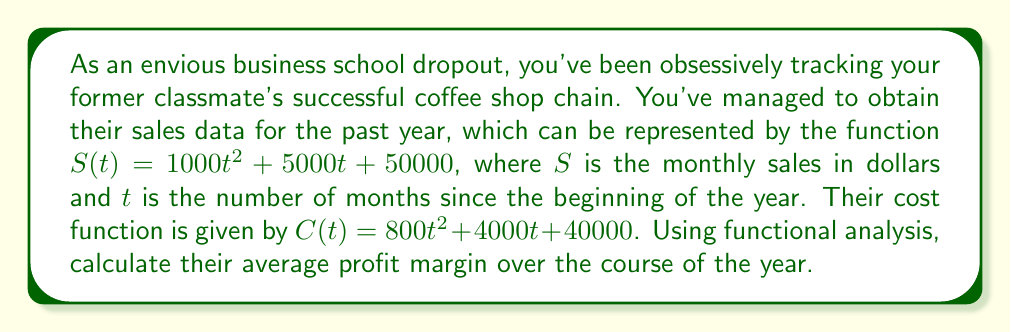What is the answer to this math problem? To solve this problem, we'll follow these steps:

1) First, let's define the profit function $P(t)$:
   $$P(t) = S(t) - C(t)$$

2) Substituting the given functions:
   $$P(t) = (1000t^2 + 5000t + 50000) - (800t^2 + 4000t + 40000)$$
   $$P(t) = 200t^2 + 1000t + 10000$$

3) To find the average profit margin, we need to calculate the average profit and the average sales over the year.

4) The average profit over the year can be calculated using the integral:
   $$\text{Average Profit} = \frac{1}{12}\int_0^{12} P(t) dt$$
   $$= \frac{1}{12}\int_0^{12} (200t^2 + 1000t + 10000) dt$$
   $$= \frac{1}{12}[\frac{200t^3}{3} + 500t^2 + 10000t]_0^{12}$$
   $$= \frac{1}{12}(11520000 + 72000000 + 120000) = 13970000$$

5) Similarly, the average sales:
   $$\text{Average Sales} = \frac{1}{12}\int_0^{12} S(t) dt$$
   $$= \frac{1}{12}\int_0^{12} (1000t^2 + 5000t + 50000) dt$$
   $$= \frac{1}{12}[\frac{1000t^3}{3} + 2500t^2 + 50000t]_0^{12}$$
   $$= \frac{1}{12}(576000000 + 360000000 + 600000) = 78050000$$

6) The average profit margin is the ratio of average profit to average sales:
   $$\text{Average Profit Margin} = \frac{\text{Average Profit}}{\text{Average Sales}}$$
   $$= \frac{13970000}{78050000} \approx 0.1789 = 17.89\%$$
Answer: The average profit margin over the course of the year is approximately 17.89%. 